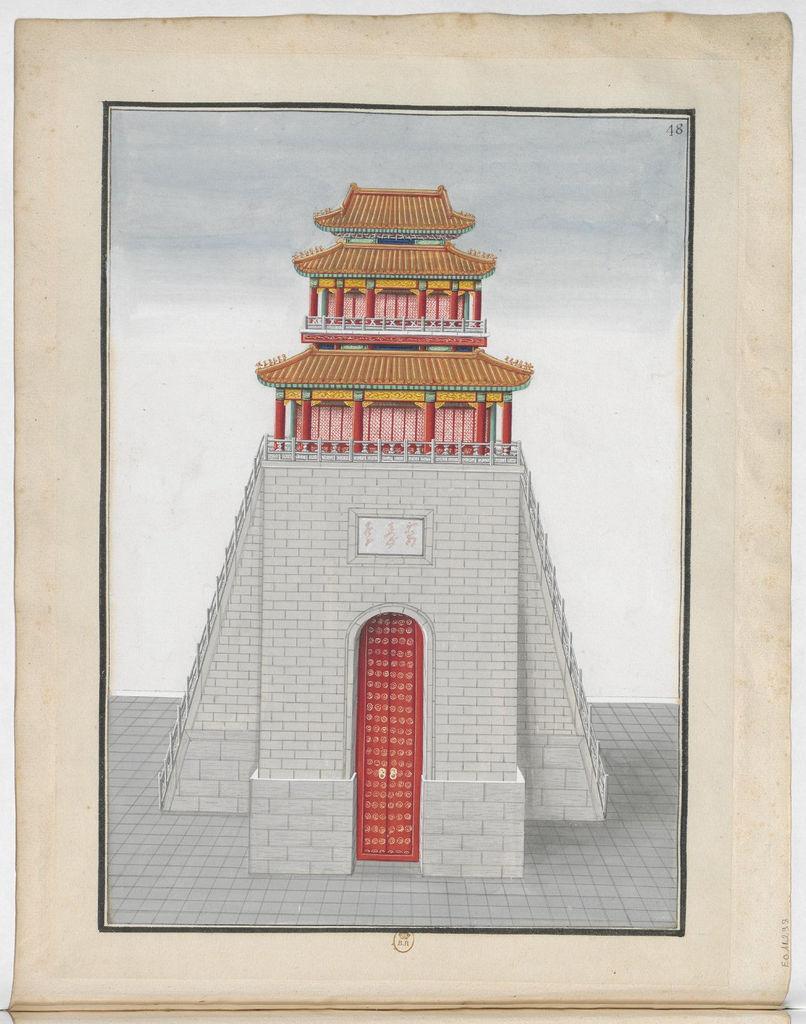How would you summarize this image in a sentence or two? In the image there is a art of a chinese temple with a big door, this seems to be a paper. 